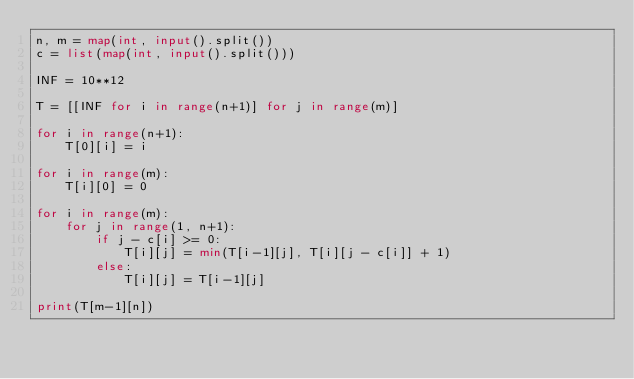Convert code to text. <code><loc_0><loc_0><loc_500><loc_500><_Python_>n, m = map(int, input().split())
c = list(map(int, input().split()))

INF = 10**12

T = [[INF for i in range(n+1)] for j in range(m)]

for i in range(n+1):
    T[0][i] = i

for i in range(m):
    T[i][0] = 0

for i in range(m):
    for j in range(1, n+1):
        if j - c[i] >= 0:
            T[i][j] = min(T[i-1][j], T[i][j - c[i]] + 1)
        else:
            T[i][j] = T[i-1][j]

print(T[m-1][n])</code> 